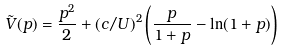Convert formula to latex. <formula><loc_0><loc_0><loc_500><loc_500>\tilde { V } ( p ) = \frac { p ^ { 2 } } { 2 } + ( c / U ) ^ { 2 } \left ( \frac { p } { 1 + p } - \ln ( 1 + p ) \right )</formula> 